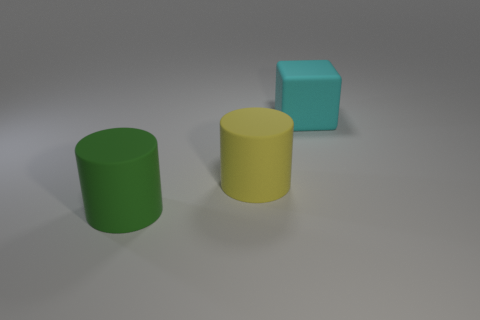Is the number of yellow objects that are to the right of the big cyan thing greater than the number of green rubber cylinders left of the large green thing?
Offer a very short reply. No. There is a yellow thing that is the same size as the green object; what is its material?
Give a very brief answer. Rubber. What shape is the cyan rubber object?
Your answer should be compact. Cube. What number of yellow objects are rubber spheres or rubber cylinders?
Ensure brevity in your answer.  1. What size is the yellow cylinder that is made of the same material as the big cyan thing?
Offer a terse response. Large. Is the cylinder that is left of the yellow cylinder made of the same material as the large object that is to the right of the yellow rubber cylinder?
Your response must be concise. Yes. What number of cylinders are large things or big brown metallic objects?
Your answer should be very brief. 2. There is a cylinder that is behind the object that is in front of the big yellow rubber thing; what number of objects are on the right side of it?
Ensure brevity in your answer.  1. There is a large yellow thing that is the same shape as the large green rubber thing; what material is it?
Your response must be concise. Rubber. Is there anything else that is the same material as the big yellow object?
Your answer should be very brief. Yes. 